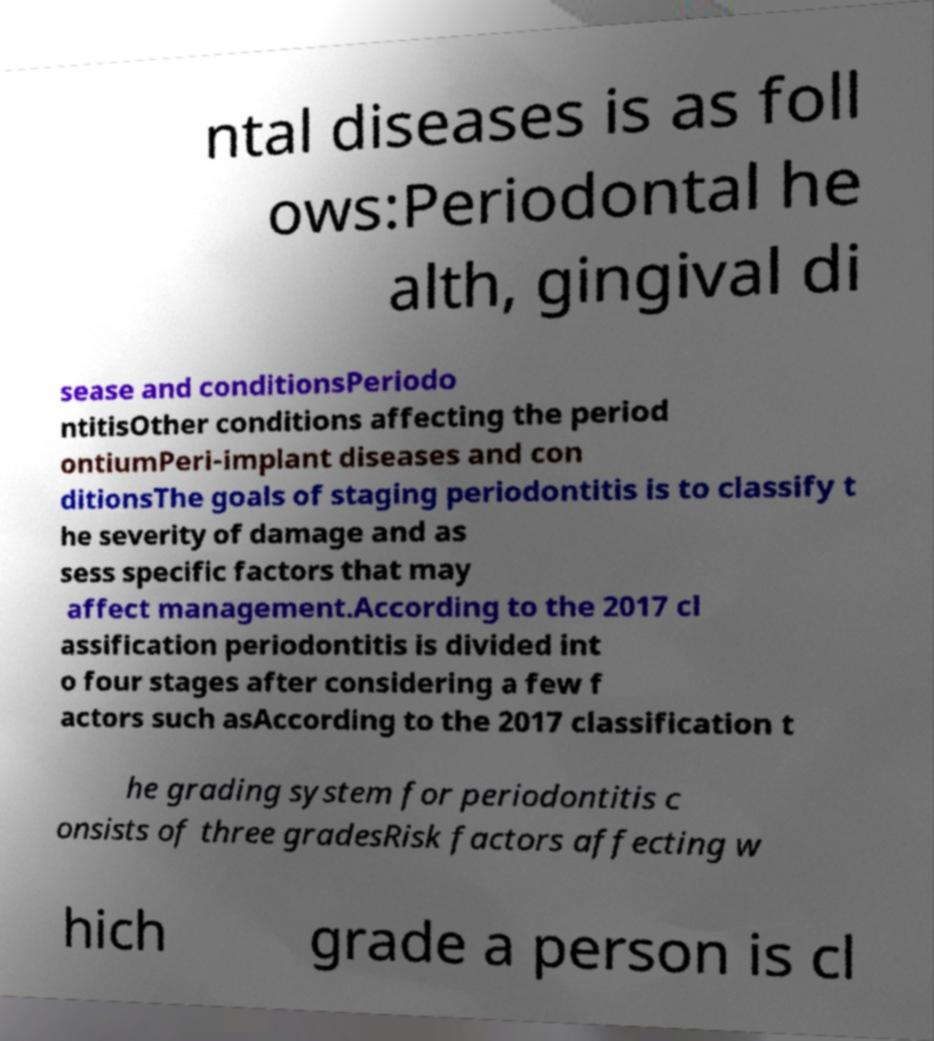Can you read and provide the text displayed in the image?This photo seems to have some interesting text. Can you extract and type it out for me? ntal diseases is as foll ows:Periodontal he alth, gingival di sease and conditionsPeriodo ntitisOther conditions affecting the period ontiumPeri-implant diseases and con ditionsThe goals of staging periodontitis is to classify t he severity of damage and as sess specific factors that may affect management.According to the 2017 cl assification periodontitis is divided int o four stages after considering a few f actors such asAccording to the 2017 classification t he grading system for periodontitis c onsists of three gradesRisk factors affecting w hich grade a person is cl 